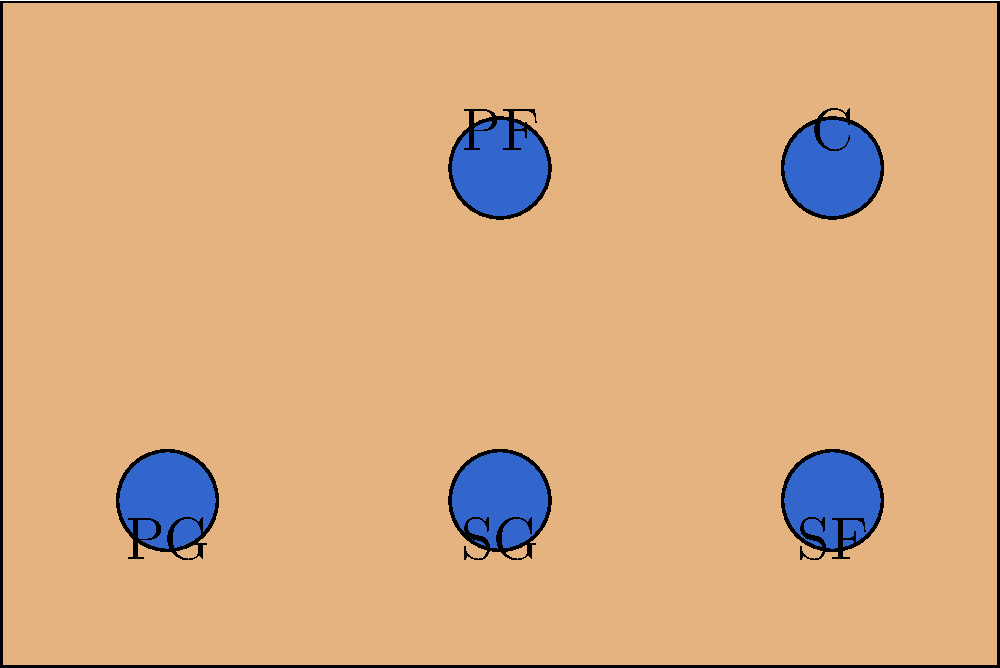As a basketball coach, you're exploring different team formations. Given that you have 12 players on your roster, with each player capable of playing any position, how many unique 5-player lineups can you create on the court, considering the specific positions shown in the diagram (PG, SG, SF, PF, C)? Let's approach this step-by-step:

1) We have 12 players in total, and we need to select 5 for the court.

2) The order matters because each selected player will be assigned to a specific position (PG, SG, SF, PF, C).

3) This scenario is a permutation problem, specifically an arrangement without repetition.

4) The formula for permutations without repetition is:
   $$P(n,r) = \frac{n!}{(n-r)!}$$
   where $n$ is the total number of items to choose from, and $r$ is the number of items being chosen.

5) In this case, $n = 12$ (total players) and $r = 5$ (players on court).

6) Plugging these numbers into our formula:
   $$P(12,5) = \frac{12!}{(12-5)!} = \frac{12!}{7!}$$

7) Calculating this out:
   $$\frac{12 * 11 * 10 * 9 * 8 * 7!}{7!} = 12 * 11 * 10 * 9 * 8 = 95,040$$

Therefore, there are 95,040 unique ways to arrange 5 players from a roster of 12 into the specific positions on the court.
Answer: 95,040 unique lineups 